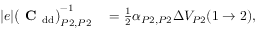Convert formula to latex. <formula><loc_0><loc_0><loc_500><loc_500>\begin{array} { r l } { | e | \left ( C _ { d d } \right ) _ { P 2 , P 2 } ^ { - 1 } } & = \frac { 1 } { 2 } \alpha _ { P 2 , P 2 } \Delta V _ { P 2 } ( 1 \to 2 ) , } \end{array}</formula> 